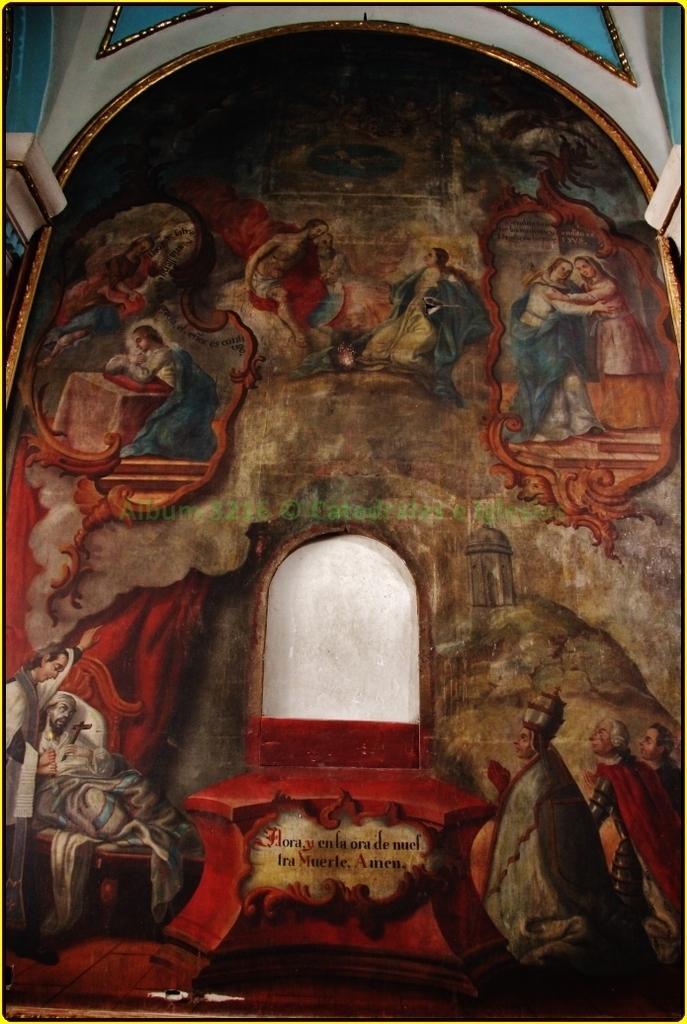Please provide a concise description of this image. In this picture I can see frame to the wall, in which there are some people. 